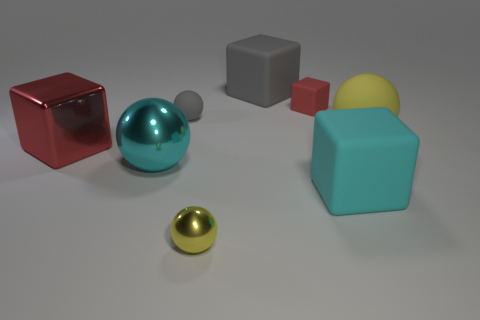There is a cyan object left of the gray thing in front of the red thing right of the cyan metallic object; what is its material?
Your response must be concise. Metal. How many shiny things are either big cyan things or large balls?
Offer a very short reply. 1. Is the color of the metal cube the same as the large metallic sphere?
Offer a very short reply. No. Are there any other things that have the same material as the big yellow object?
Offer a terse response. Yes. How many things are large spheres or rubber balls to the left of the cyan rubber object?
Provide a succinct answer. 3. There is a matte cube that is in front of the gray matte ball; is its size the same as the big shiny block?
Make the answer very short. Yes. How many other things are there of the same shape as the big yellow matte object?
Your response must be concise. 3. What number of cyan objects are either large rubber spheres or metallic things?
Give a very brief answer. 1. Do the small rubber object in front of the tiny matte cube and the big metal cube have the same color?
Provide a succinct answer. No. What is the shape of the cyan thing that is the same material as the small cube?
Offer a very short reply. Cube. 